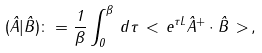<formula> <loc_0><loc_0><loc_500><loc_500>( \hat { A } | \hat { B } ) \colon = \frac { 1 } { \beta } \int _ { 0 } ^ { \beta } \, d \tau \, < \, e ^ { \tau L } \hat { A } ^ { + } \cdot \hat { B } \, > \, ,</formula> 